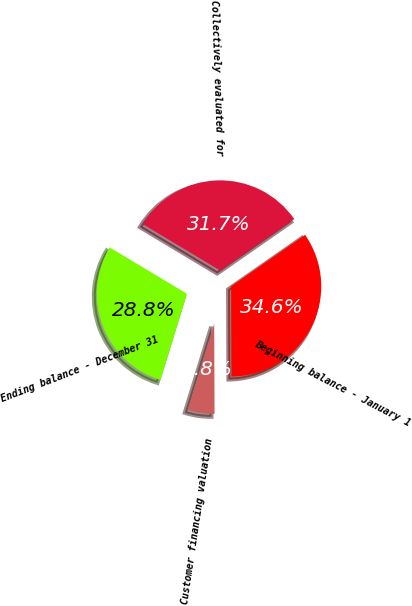Convert chart to OTSL. <chart><loc_0><loc_0><loc_500><loc_500><pie_chart><fcel>Beginning balance - January 1<fcel>Customer financing valuation<fcel>Ending balance - December 31<fcel>Collectively evaluated for<nl><fcel>34.62%<fcel>4.81%<fcel>28.85%<fcel>31.73%<nl></chart> 